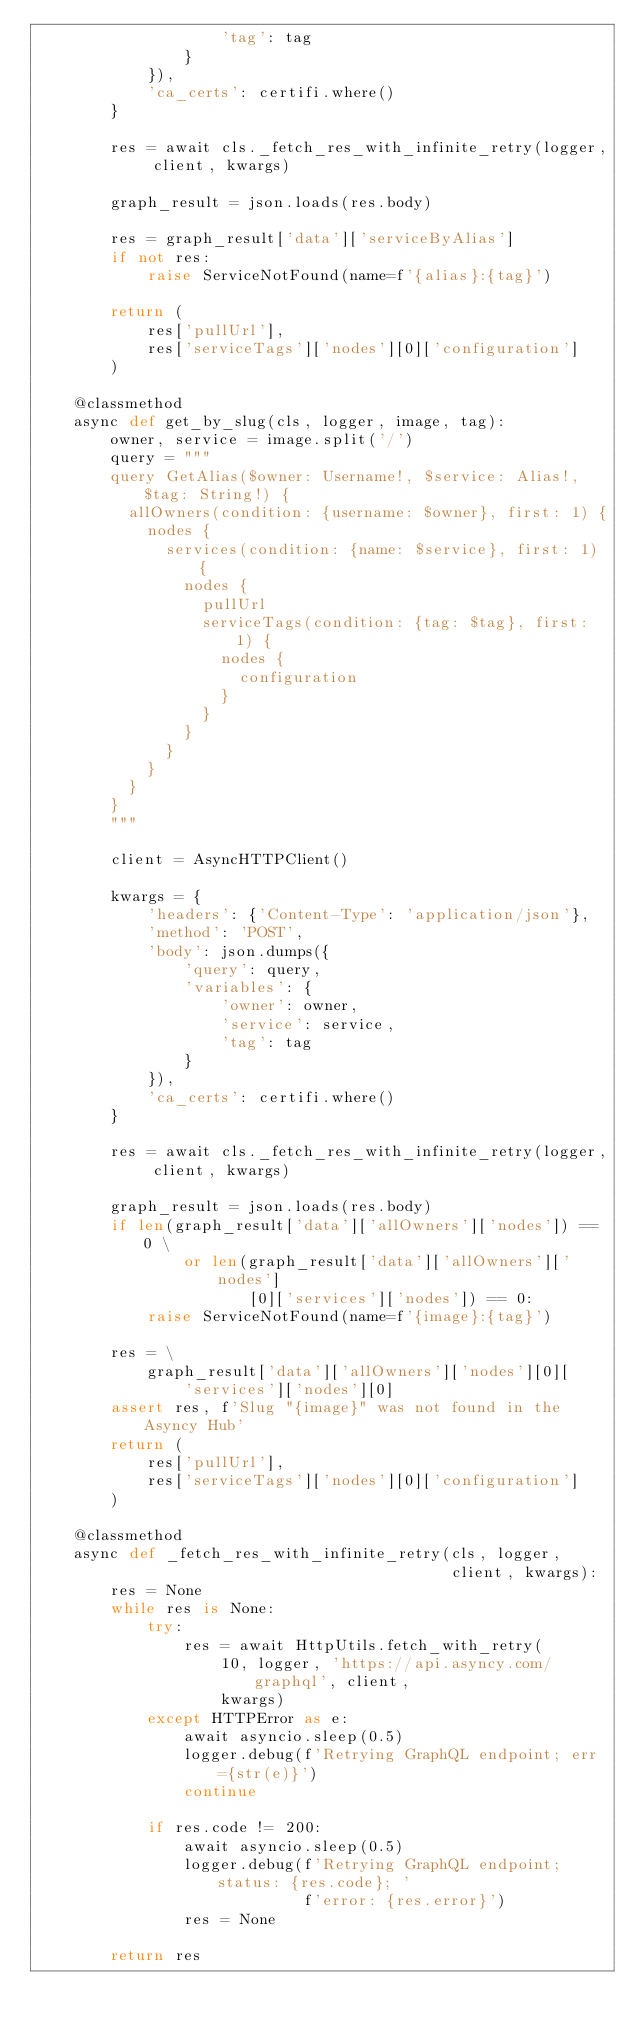Convert code to text. <code><loc_0><loc_0><loc_500><loc_500><_Python_>                    'tag': tag
                }
            }),
            'ca_certs': certifi.where()
        }

        res = await cls._fetch_res_with_infinite_retry(logger, client, kwargs)

        graph_result = json.loads(res.body)

        res = graph_result['data']['serviceByAlias']
        if not res:
            raise ServiceNotFound(name=f'{alias}:{tag}')

        return (
            res['pullUrl'],
            res['serviceTags']['nodes'][0]['configuration']
        )

    @classmethod
    async def get_by_slug(cls, logger, image, tag):
        owner, service = image.split('/')
        query = """
        query GetAlias($owner: Username!, $service: Alias!, $tag: String!) {
          allOwners(condition: {username: $owner}, first: 1) {
            nodes {
              services(condition: {name: $service}, first: 1) {
                nodes {
                  pullUrl
                  serviceTags(condition: {tag: $tag}, first: 1) {
                    nodes {
                      configuration
                    }
                  }
                }
              }
            }
          }
        }
        """

        client = AsyncHTTPClient()

        kwargs = {
            'headers': {'Content-Type': 'application/json'},
            'method': 'POST',
            'body': json.dumps({
                'query': query,
                'variables': {
                    'owner': owner,
                    'service': service,
                    'tag': tag
                }
            }),
            'ca_certs': certifi.where()
        }

        res = await cls._fetch_res_with_infinite_retry(logger, client, kwargs)

        graph_result = json.loads(res.body)
        if len(graph_result['data']['allOwners']['nodes']) == 0 \
                or len(graph_result['data']['allOwners']['nodes']
                       [0]['services']['nodes']) == 0:
            raise ServiceNotFound(name=f'{image}:{tag}')

        res = \
            graph_result['data']['allOwners']['nodes'][0][
                'services']['nodes'][0]
        assert res, f'Slug "{image}" was not found in the Asyncy Hub'
        return (
            res['pullUrl'],
            res['serviceTags']['nodes'][0]['configuration']
        )

    @classmethod
    async def _fetch_res_with_infinite_retry(cls, logger,
                                             client, kwargs):
        res = None
        while res is None:
            try:
                res = await HttpUtils.fetch_with_retry(
                    10, logger, 'https://api.asyncy.com/graphql', client,
                    kwargs)
            except HTTPError as e:
                await asyncio.sleep(0.5)
                logger.debug(f'Retrying GraphQL endpoint; err={str(e)}')
                continue

            if res.code != 200:
                await asyncio.sleep(0.5)
                logger.debug(f'Retrying GraphQL endpoint; status: {res.code}; '
                             f'error: {res.error}')
                res = None

        return res
</code> 